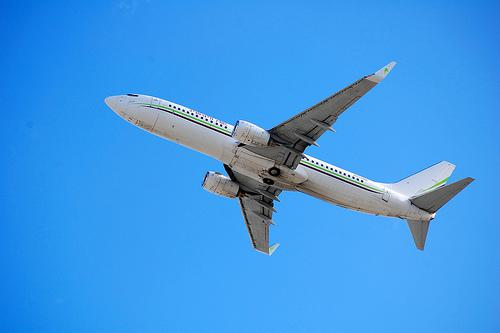How many unicorns are there in the image? 0 